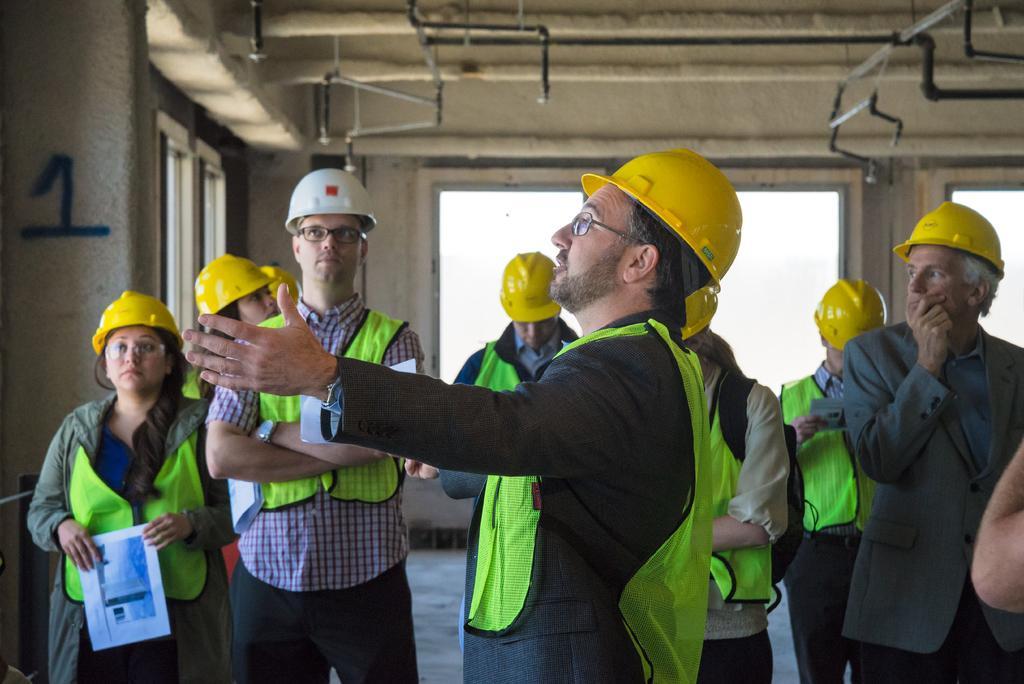How would you summarize this image in a sentence or two? In this picture we can see a group of people wore helmets and standing on the floor and in the background we can see windows, rods. 